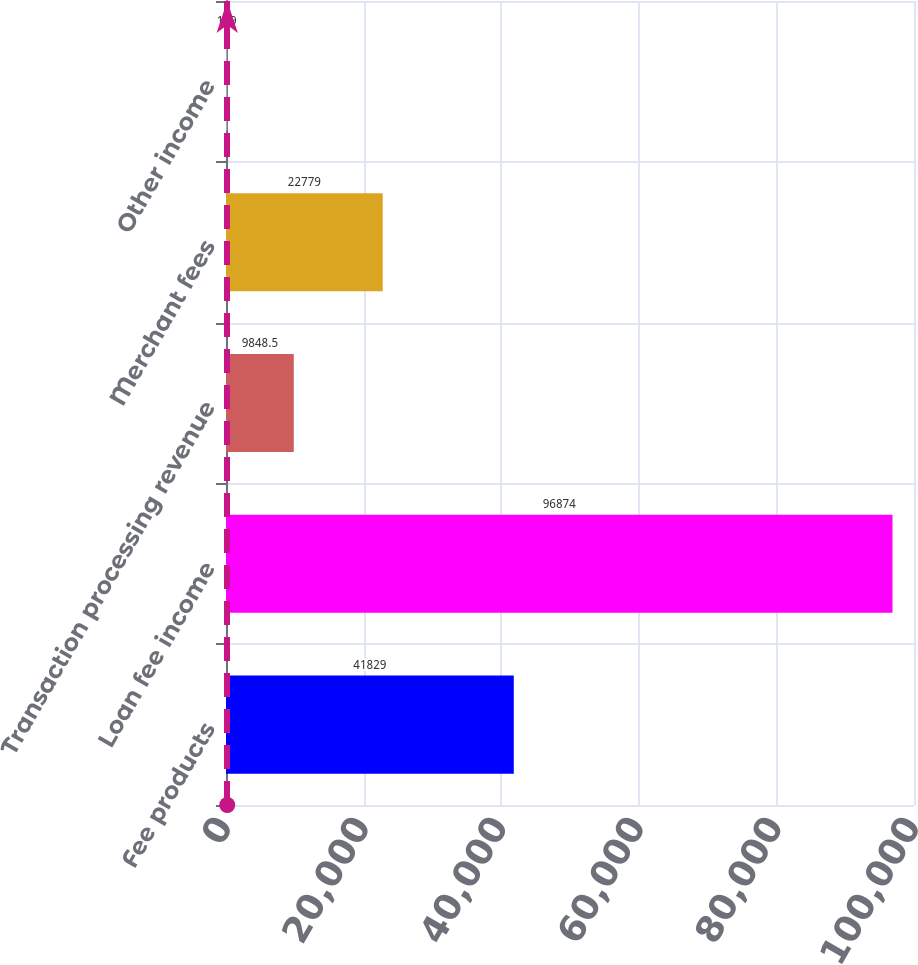Convert chart. <chart><loc_0><loc_0><loc_500><loc_500><bar_chart><fcel>Fee products<fcel>Loan fee income<fcel>Transaction processing revenue<fcel>Merchant fees<fcel>Other income<nl><fcel>41829<fcel>96874<fcel>9848.5<fcel>22779<fcel>179<nl></chart> 